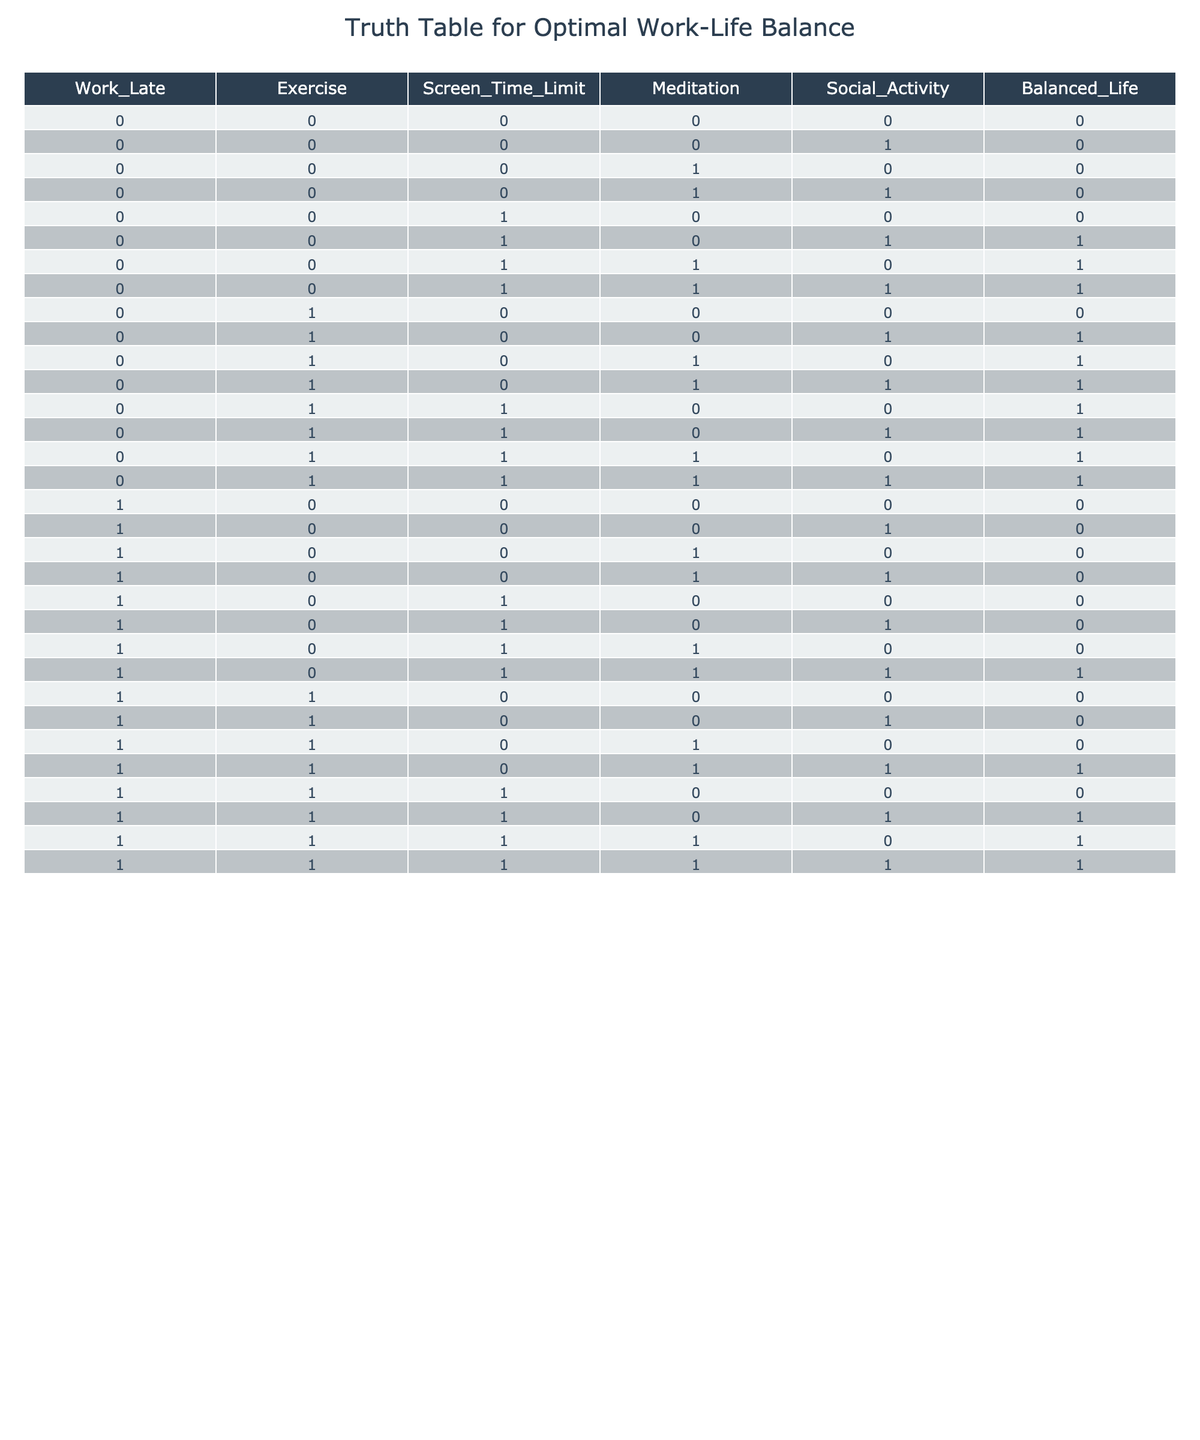What is the value of Balanced Life when Work_Late is 0, Exercise is 0, and Social Activity is 1? In the table, we look for the row where Work_Late is 0, Exercise is 0, and Social Activity is 1. The corresponding Balanced Life value for that combination is located in the column for Balanced Life in the same row. We find this in the fifth row of the table, where the value is 0.
Answer: 0 How many scenarios result in a Balanced Life of 1 when Work_Late is 0? We need to count the number of rows where Work_Late is 0 and Balanced Life is 1. By inspecting the table, we find there are four such instances: rows 6, 7, 8, and 10. Thus, the count is 4.
Answer: 4 Is it true that if Exercise is 1, there will always be a Balanced Life of 1? To determine this, we look at all rows where Exercise is 1. In the table, we find there are rows with Exercise equal to 1 that have Balanced Life values of both 0 and 1. Specifically, rows with Exercise = 1 and Balanced Life = 0 show that this statement is false.
Answer: No What is the total number of scenarios where both Screen Time Limit is 1 and Meditation is 1? We count the instances in the table where Screen Time Limit equals 1 and Meditation also equals 1. By looking at the relevant rows, we find this occurs in rows 14, 15, and 16, making a total of 3 scenarios where both conditions are satisfied.
Answer: 3 What is the percentage of scenarios that achieve a Balanced Life of 0? First, we need to count the total number of scenarios in the table, which is 32. Next, we find the instances where Balanced Life is 0. There are 16 occurrences of a Balanced Life of 0 in the table. To find the percentage, we calculate (16/32) * 100, giving us 50%.
Answer: 50% When Work_Late is 1, how many scenarios include both Exercise and Meditation as 0? We check the rows where Work_Late is 1 and count how many have Exercise as 0 and Meditation as 0. There are rows 17, 18, 19, and 20 that fit this criteria, resulting in a total of 4 scenarios.
Answer: 4 Is it possible to achieve a Balanced Life of 1 with Work_Late being 1? Looking at the rows where Work_Late equals 1, we find that there are scenarios with Balanced Life equal to 1, specifically rows 13, 14, 15, and 16. This indicates that it is indeed possible to achieve a Balanced Life of 1 under these conditions.
Answer: Yes What is the most common combination of factors that lead to a Balanced Life of 1? To determine this, we go through all rows with Balanced Life equal to 1 and check the combinations of Work_Late, Exercise, Screen_Time_Limit, Meditation, and Social Activity. By summarizing these combinations, the most common one found is Work_Late = 0, Exercise = 1, and Social Activity = 1, reflected in multiple rows contributing to the balanced life being 1.
Answer: Work_Late = 0, Exercise = 1, Social Activity = 1 